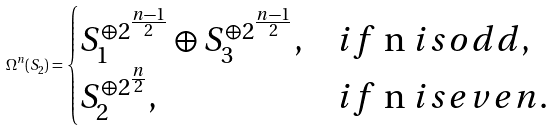<formula> <loc_0><loc_0><loc_500><loc_500>\Omega ^ { n } ( S _ { 2 } ) = \begin{cases} S _ { 1 } ^ { \oplus 2 ^ { \frac { n - 1 } { 2 } } } \oplus S _ { 3 } ^ { \oplus 2 ^ { \frac { n - 1 } { 2 } } } , & i f $ n $ i s o d d , \\ S _ { 2 } ^ { \oplus 2 ^ { \frac { n } { 2 } } } , & i f $ n $ i s e v e n . \end{cases}</formula> 